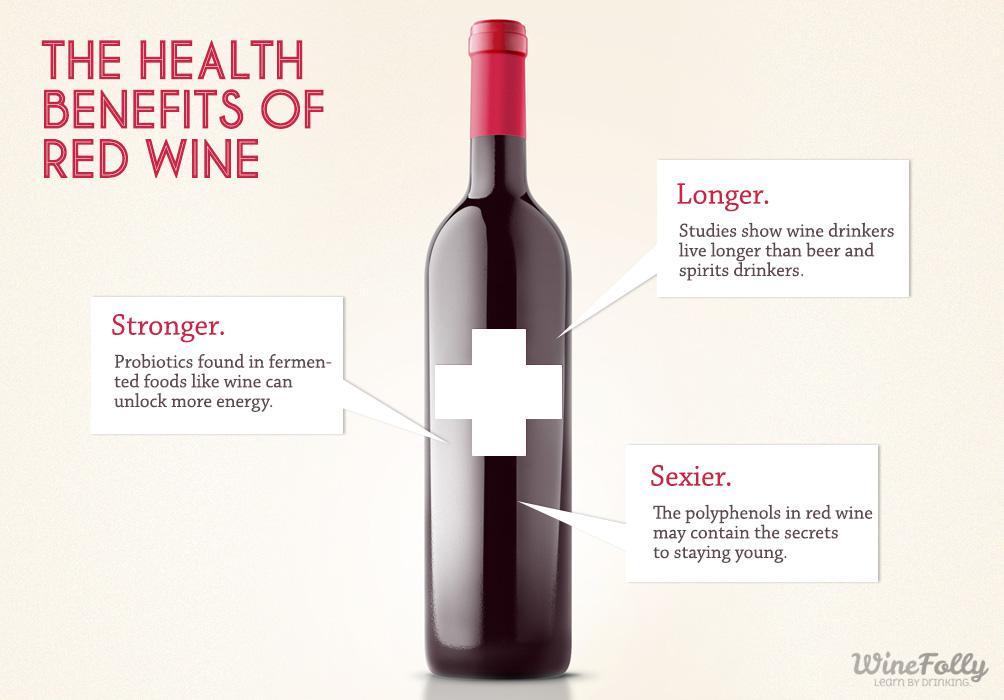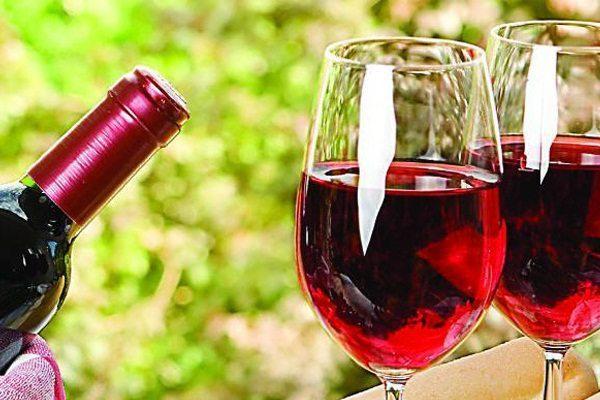The first image is the image on the left, the second image is the image on the right. Assess this claim about the two images: "At least one image shows wine bottles stored in a rack.". Correct or not? Answer yes or no. No. 